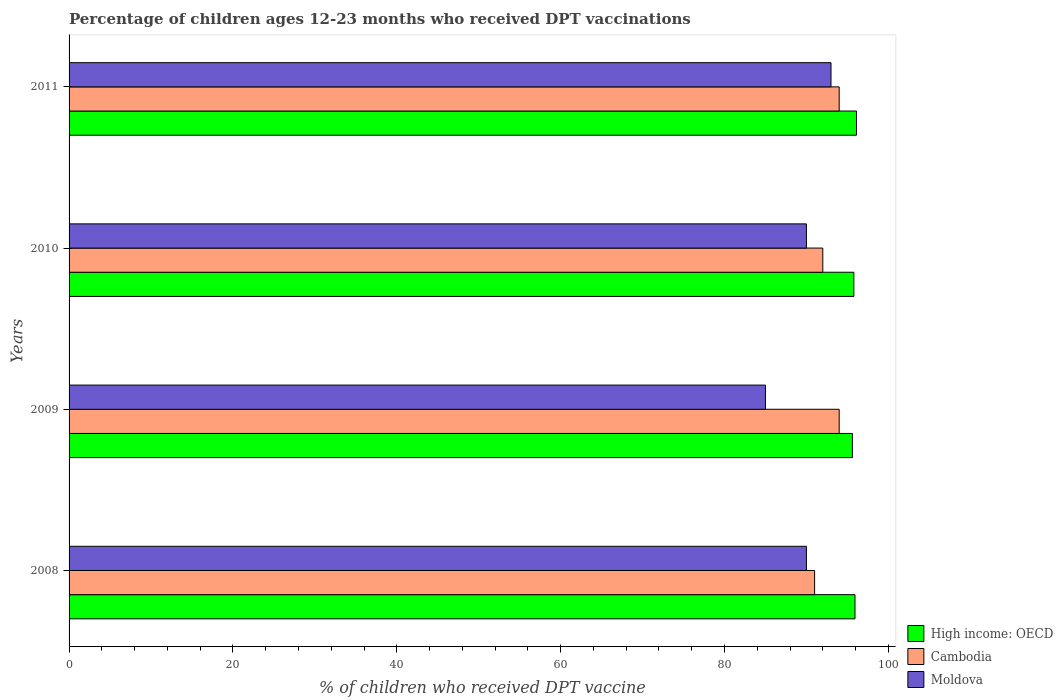How many different coloured bars are there?
Offer a very short reply. 3. How many bars are there on the 2nd tick from the top?
Provide a succinct answer. 3. In how many cases, is the number of bars for a given year not equal to the number of legend labels?
Offer a terse response. 0. What is the percentage of children who received DPT vaccination in High income: OECD in 2009?
Offer a very short reply. 95.61. Across all years, what is the maximum percentage of children who received DPT vaccination in Cambodia?
Keep it short and to the point. 94. Across all years, what is the minimum percentage of children who received DPT vaccination in High income: OECD?
Your response must be concise. 95.61. In which year was the percentage of children who received DPT vaccination in High income: OECD maximum?
Your answer should be compact. 2011. In which year was the percentage of children who received DPT vaccination in Moldova minimum?
Provide a short and direct response. 2009. What is the total percentage of children who received DPT vaccination in Cambodia in the graph?
Give a very brief answer. 371. What is the difference between the percentage of children who received DPT vaccination in Moldova in 2008 and that in 2011?
Give a very brief answer. -3. What is the difference between the percentage of children who received DPT vaccination in High income: OECD in 2010 and the percentage of children who received DPT vaccination in Cambodia in 2008?
Provide a short and direct response. 4.79. What is the average percentage of children who received DPT vaccination in Cambodia per year?
Offer a very short reply. 92.75. In how many years, is the percentage of children who received DPT vaccination in Cambodia greater than 12 %?
Make the answer very short. 4. What is the ratio of the percentage of children who received DPT vaccination in Moldova in 2009 to that in 2011?
Provide a succinct answer. 0.91. What is the difference between the highest and the second highest percentage of children who received DPT vaccination in Moldova?
Offer a terse response. 3. What is the difference between the highest and the lowest percentage of children who received DPT vaccination in High income: OECD?
Keep it short and to the point. 0.5. Is the sum of the percentage of children who received DPT vaccination in Moldova in 2008 and 2011 greater than the maximum percentage of children who received DPT vaccination in High income: OECD across all years?
Keep it short and to the point. Yes. What does the 2nd bar from the top in 2011 represents?
Provide a short and direct response. Cambodia. What does the 2nd bar from the bottom in 2008 represents?
Give a very brief answer. Cambodia. Is it the case that in every year, the sum of the percentage of children who received DPT vaccination in High income: OECD and percentage of children who received DPT vaccination in Cambodia is greater than the percentage of children who received DPT vaccination in Moldova?
Offer a very short reply. Yes. How many bars are there?
Give a very brief answer. 12. Are all the bars in the graph horizontal?
Make the answer very short. Yes. What is the difference between two consecutive major ticks on the X-axis?
Provide a short and direct response. 20. Are the values on the major ticks of X-axis written in scientific E-notation?
Your answer should be compact. No. Does the graph contain grids?
Offer a very short reply. No. How many legend labels are there?
Give a very brief answer. 3. What is the title of the graph?
Keep it short and to the point. Percentage of children ages 12-23 months who received DPT vaccinations. What is the label or title of the X-axis?
Give a very brief answer. % of children who received DPT vaccine. What is the label or title of the Y-axis?
Your answer should be compact. Years. What is the % of children who received DPT vaccine in High income: OECD in 2008?
Your answer should be compact. 95.93. What is the % of children who received DPT vaccine of Cambodia in 2008?
Your answer should be very brief. 91. What is the % of children who received DPT vaccine of High income: OECD in 2009?
Offer a very short reply. 95.61. What is the % of children who received DPT vaccine in Cambodia in 2009?
Your response must be concise. 94. What is the % of children who received DPT vaccine in Moldova in 2009?
Offer a very short reply. 85. What is the % of children who received DPT vaccine of High income: OECD in 2010?
Offer a very short reply. 95.79. What is the % of children who received DPT vaccine of Cambodia in 2010?
Your answer should be compact. 92. What is the % of children who received DPT vaccine of Moldova in 2010?
Your response must be concise. 90. What is the % of children who received DPT vaccine of High income: OECD in 2011?
Make the answer very short. 96.11. What is the % of children who received DPT vaccine in Cambodia in 2011?
Make the answer very short. 94. What is the % of children who received DPT vaccine of Moldova in 2011?
Offer a terse response. 93. Across all years, what is the maximum % of children who received DPT vaccine of High income: OECD?
Give a very brief answer. 96.11. Across all years, what is the maximum % of children who received DPT vaccine of Cambodia?
Provide a succinct answer. 94. Across all years, what is the maximum % of children who received DPT vaccine of Moldova?
Ensure brevity in your answer.  93. Across all years, what is the minimum % of children who received DPT vaccine of High income: OECD?
Ensure brevity in your answer.  95.61. Across all years, what is the minimum % of children who received DPT vaccine in Cambodia?
Make the answer very short. 91. What is the total % of children who received DPT vaccine of High income: OECD in the graph?
Your answer should be very brief. 383.45. What is the total % of children who received DPT vaccine in Cambodia in the graph?
Provide a short and direct response. 371. What is the total % of children who received DPT vaccine in Moldova in the graph?
Give a very brief answer. 358. What is the difference between the % of children who received DPT vaccine in High income: OECD in 2008 and that in 2009?
Your answer should be very brief. 0.32. What is the difference between the % of children who received DPT vaccine in Cambodia in 2008 and that in 2009?
Provide a succinct answer. -3. What is the difference between the % of children who received DPT vaccine in High income: OECD in 2008 and that in 2010?
Offer a very short reply. 0.14. What is the difference between the % of children who received DPT vaccine in High income: OECD in 2008 and that in 2011?
Offer a terse response. -0.18. What is the difference between the % of children who received DPT vaccine in Moldova in 2008 and that in 2011?
Keep it short and to the point. -3. What is the difference between the % of children who received DPT vaccine of High income: OECD in 2009 and that in 2010?
Provide a short and direct response. -0.18. What is the difference between the % of children who received DPT vaccine in High income: OECD in 2009 and that in 2011?
Ensure brevity in your answer.  -0.5. What is the difference between the % of children who received DPT vaccine in Cambodia in 2009 and that in 2011?
Give a very brief answer. 0. What is the difference between the % of children who received DPT vaccine in High income: OECD in 2010 and that in 2011?
Provide a short and direct response. -0.32. What is the difference between the % of children who received DPT vaccine in Cambodia in 2010 and that in 2011?
Keep it short and to the point. -2. What is the difference between the % of children who received DPT vaccine in High income: OECD in 2008 and the % of children who received DPT vaccine in Cambodia in 2009?
Give a very brief answer. 1.93. What is the difference between the % of children who received DPT vaccine of High income: OECD in 2008 and the % of children who received DPT vaccine of Moldova in 2009?
Offer a terse response. 10.93. What is the difference between the % of children who received DPT vaccine in High income: OECD in 2008 and the % of children who received DPT vaccine in Cambodia in 2010?
Your answer should be very brief. 3.93. What is the difference between the % of children who received DPT vaccine of High income: OECD in 2008 and the % of children who received DPT vaccine of Moldova in 2010?
Offer a very short reply. 5.93. What is the difference between the % of children who received DPT vaccine in High income: OECD in 2008 and the % of children who received DPT vaccine in Cambodia in 2011?
Offer a very short reply. 1.93. What is the difference between the % of children who received DPT vaccine in High income: OECD in 2008 and the % of children who received DPT vaccine in Moldova in 2011?
Make the answer very short. 2.93. What is the difference between the % of children who received DPT vaccine in Cambodia in 2008 and the % of children who received DPT vaccine in Moldova in 2011?
Offer a very short reply. -2. What is the difference between the % of children who received DPT vaccine in High income: OECD in 2009 and the % of children who received DPT vaccine in Cambodia in 2010?
Provide a succinct answer. 3.61. What is the difference between the % of children who received DPT vaccine in High income: OECD in 2009 and the % of children who received DPT vaccine in Moldova in 2010?
Provide a succinct answer. 5.61. What is the difference between the % of children who received DPT vaccine in High income: OECD in 2009 and the % of children who received DPT vaccine in Cambodia in 2011?
Ensure brevity in your answer.  1.61. What is the difference between the % of children who received DPT vaccine in High income: OECD in 2009 and the % of children who received DPT vaccine in Moldova in 2011?
Provide a succinct answer. 2.61. What is the difference between the % of children who received DPT vaccine of High income: OECD in 2010 and the % of children who received DPT vaccine of Cambodia in 2011?
Your answer should be very brief. 1.79. What is the difference between the % of children who received DPT vaccine of High income: OECD in 2010 and the % of children who received DPT vaccine of Moldova in 2011?
Offer a terse response. 2.79. What is the average % of children who received DPT vaccine of High income: OECD per year?
Your answer should be very brief. 95.86. What is the average % of children who received DPT vaccine of Cambodia per year?
Your response must be concise. 92.75. What is the average % of children who received DPT vaccine in Moldova per year?
Your answer should be compact. 89.5. In the year 2008, what is the difference between the % of children who received DPT vaccine of High income: OECD and % of children who received DPT vaccine of Cambodia?
Give a very brief answer. 4.93. In the year 2008, what is the difference between the % of children who received DPT vaccine of High income: OECD and % of children who received DPT vaccine of Moldova?
Offer a terse response. 5.93. In the year 2009, what is the difference between the % of children who received DPT vaccine in High income: OECD and % of children who received DPT vaccine in Cambodia?
Provide a succinct answer. 1.61. In the year 2009, what is the difference between the % of children who received DPT vaccine in High income: OECD and % of children who received DPT vaccine in Moldova?
Keep it short and to the point. 10.61. In the year 2010, what is the difference between the % of children who received DPT vaccine in High income: OECD and % of children who received DPT vaccine in Cambodia?
Offer a very short reply. 3.79. In the year 2010, what is the difference between the % of children who received DPT vaccine in High income: OECD and % of children who received DPT vaccine in Moldova?
Your answer should be very brief. 5.79. In the year 2011, what is the difference between the % of children who received DPT vaccine in High income: OECD and % of children who received DPT vaccine in Cambodia?
Ensure brevity in your answer.  2.11. In the year 2011, what is the difference between the % of children who received DPT vaccine in High income: OECD and % of children who received DPT vaccine in Moldova?
Make the answer very short. 3.11. What is the ratio of the % of children who received DPT vaccine in Cambodia in 2008 to that in 2009?
Provide a succinct answer. 0.97. What is the ratio of the % of children who received DPT vaccine of Moldova in 2008 to that in 2009?
Your answer should be very brief. 1.06. What is the ratio of the % of children who received DPT vaccine in Moldova in 2008 to that in 2010?
Your response must be concise. 1. What is the ratio of the % of children who received DPT vaccine in Cambodia in 2008 to that in 2011?
Your answer should be compact. 0.97. What is the ratio of the % of children who received DPT vaccine in Cambodia in 2009 to that in 2010?
Give a very brief answer. 1.02. What is the ratio of the % of children who received DPT vaccine in Moldova in 2009 to that in 2010?
Keep it short and to the point. 0.94. What is the ratio of the % of children who received DPT vaccine in High income: OECD in 2009 to that in 2011?
Ensure brevity in your answer.  0.99. What is the ratio of the % of children who received DPT vaccine of Cambodia in 2009 to that in 2011?
Provide a short and direct response. 1. What is the ratio of the % of children who received DPT vaccine in Moldova in 2009 to that in 2011?
Ensure brevity in your answer.  0.91. What is the ratio of the % of children who received DPT vaccine of High income: OECD in 2010 to that in 2011?
Provide a short and direct response. 1. What is the ratio of the % of children who received DPT vaccine in Cambodia in 2010 to that in 2011?
Keep it short and to the point. 0.98. What is the difference between the highest and the second highest % of children who received DPT vaccine in High income: OECD?
Ensure brevity in your answer.  0.18. What is the difference between the highest and the second highest % of children who received DPT vaccine of Moldova?
Provide a succinct answer. 3. What is the difference between the highest and the lowest % of children who received DPT vaccine of High income: OECD?
Give a very brief answer. 0.5. What is the difference between the highest and the lowest % of children who received DPT vaccine in Moldova?
Offer a very short reply. 8. 